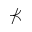Convert formula to latex. <formula><loc_0><loc_0><loc_500><loc_500>\nprec</formula> 